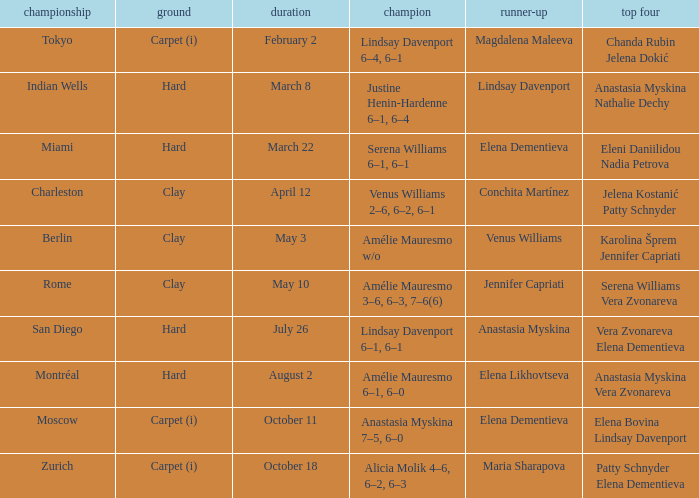Who was the winner of the Miami tournament where Elena Dementieva was a finalist? Serena Williams 6–1, 6–1. 